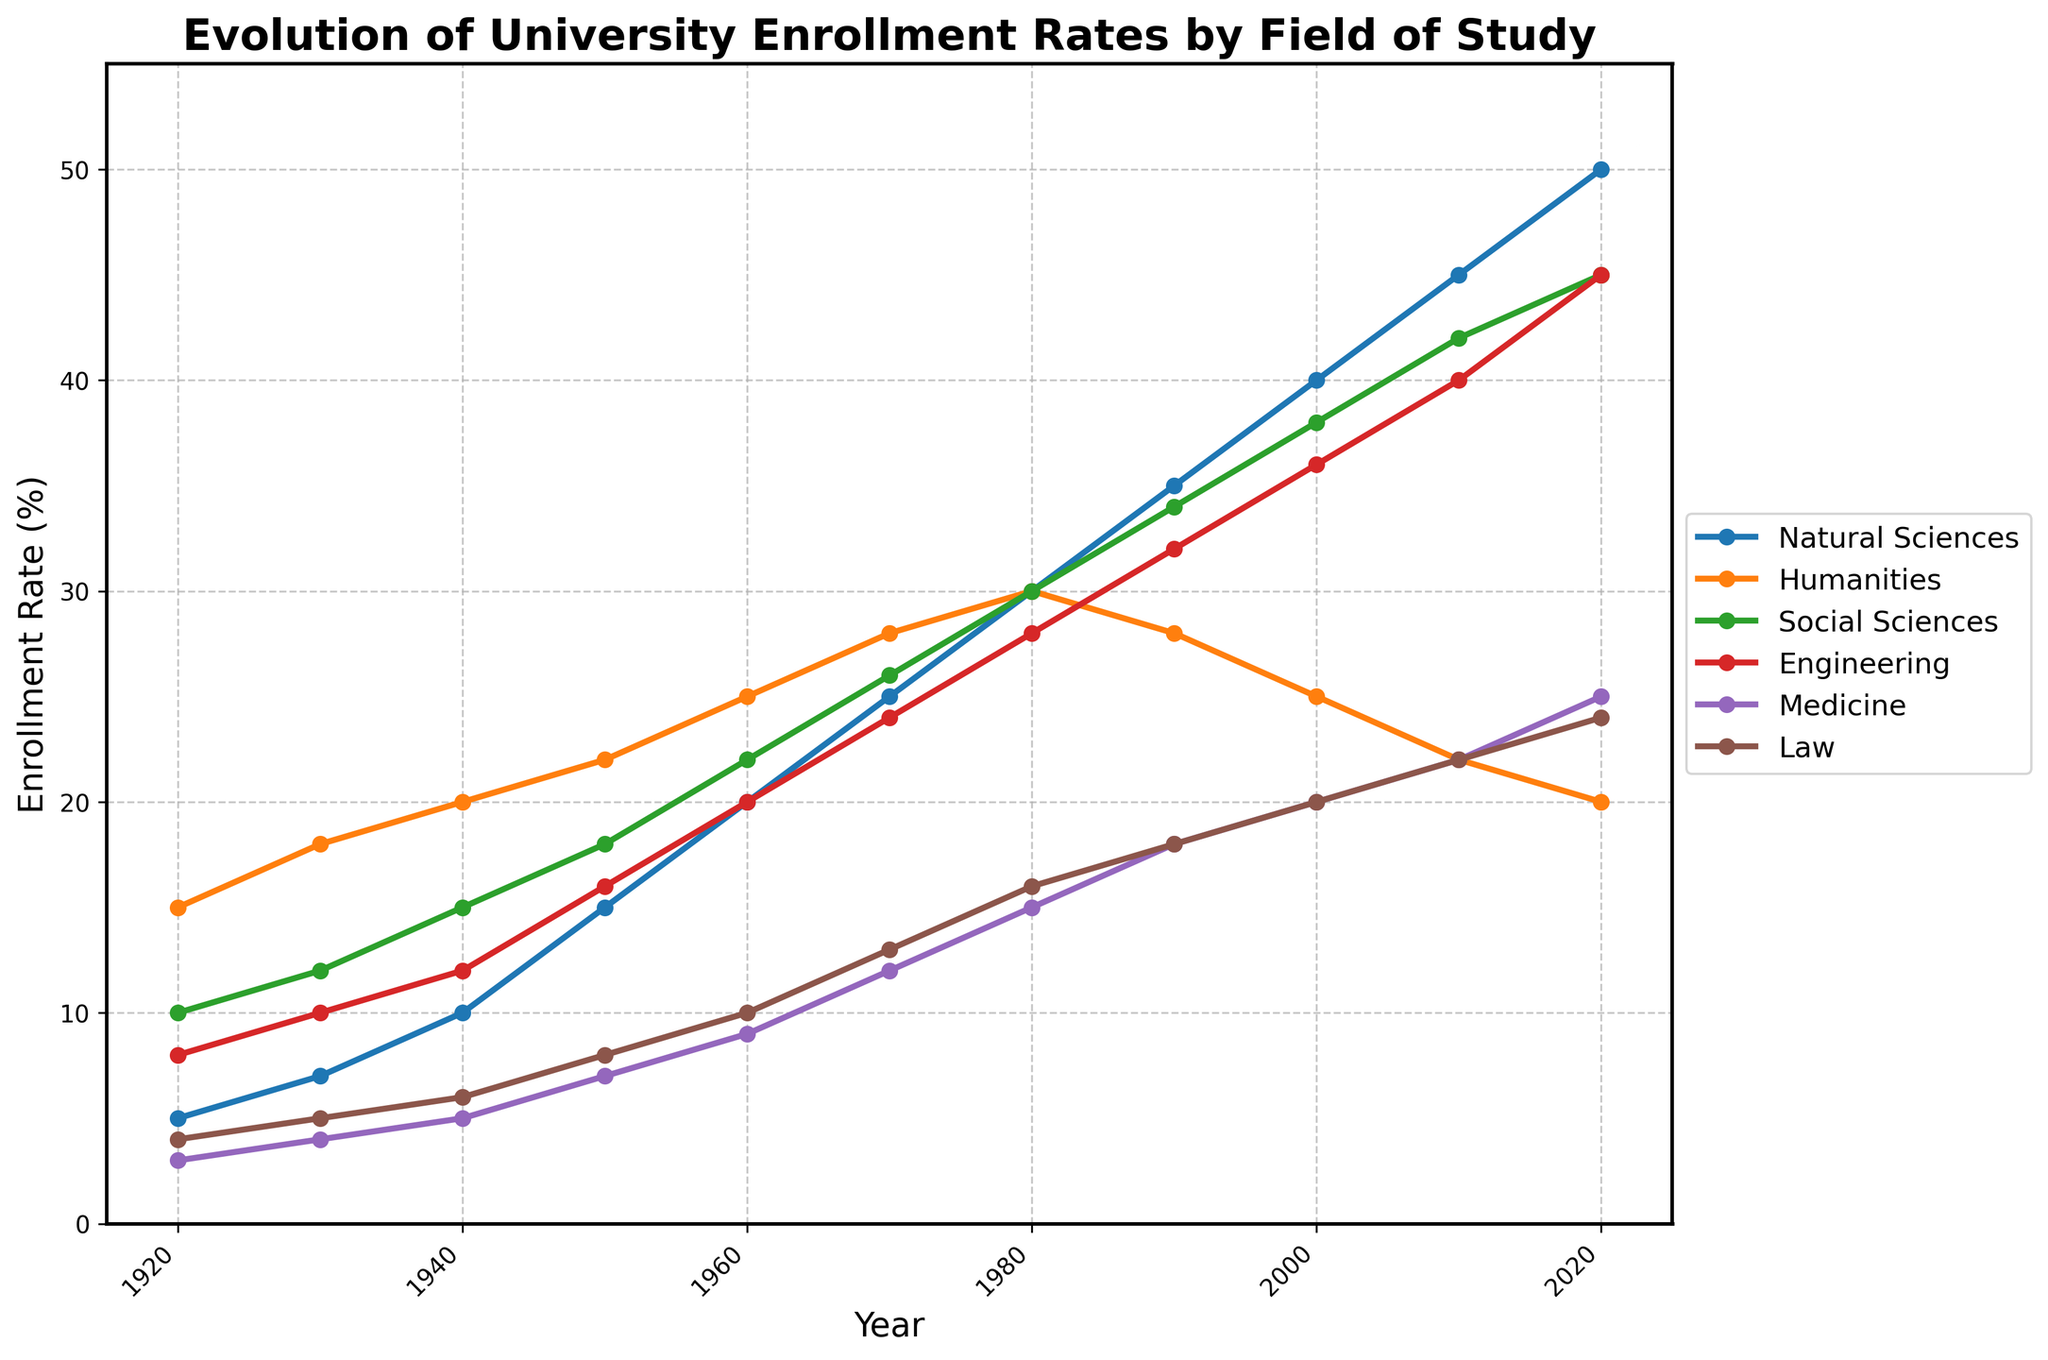What is the difference in enrollment rates between Natural Sciences and Humanities in 2020? To find the difference, look at the enrollment rates for Natural Sciences (50%) and Humanities (20%) in 2020. Subtract the Humanities rate from the Natural Sciences rate: 50% - 20% = 30%.
Answer: 30% Which field experienced the highest increase in enrollment rate from 1920 to 2020? Compare the initial and final values for each field. Natural Sciences increased from 5% to 50%, Humanities from 15% to 20%, Social Sciences from 10% to 45%, Engineering from 8% to 45%, Medicine from 3% to 25%, and Law from 4% to 24%. Natural Sciences and Engineering both increased by 45 percentage points.
Answer: Natural Sciences and Engineering Which field had the steepest decline in enrollment rate in the past century? Compare the start and end points for each field. Humanities declined the most, from 15% in 1920 to 20% in 2020, which is a decline of 5 percentage points, while others either increased or declined less.
Answer: Humanities In which year did Engineering enrollment rates surpass those of Humanities? Track the lines representing Engineering and Humanities. Engineering enrollment rates surpassed Humanities between 1980 and 1990. Humanities were higher in 1980 (30% vs. 28%), but lower in 1990 (28% vs. 32%).
Answer: Between 1980 and 1990 Between which decades did Medicine see the most significant increase in enrollment rates? Compare the increases in enrollment rates for Medicine across each decade. from 1920 to 1930, it increases by 1 percentage point. From 1930 to 1940, by 1 point. From 1960 to 1970, by 3 points. From 1970 to 1980, by 3 points. From 1980 to 1990, by 3 points. From 1990 to 2020, Enrollment rates stayed the same.
Answer: Between 1970 and 1980 What is the average enrollment rate for Law across all the displayed years? To calculate the average, sum the Law enrollment rates for each year: 4, 5, 6, 8, 10, 13, 16, 18, 20, 22, 24. Then divide by the number of years (11). (4 + 5 + 6 + 8 + 10 + 13 + 16 + 18 + 20 + 22 + 24) / 11 = 146 / 11 ≈ 13.27.
Answer: 13.27% In what year did Social Sciences have the highest enrollment rate? Identify the peak of the Social Sciences line. The highest value is 45% in 2020.
Answer: 2020 How many fields had higher enrollment rates in 2010 compared to 1990? Compare each field's enrollment rate in 1990 to its rate in 2010. Natural Sciences increased from 35% to 45%, Humanities decreased from 28% to 22%, Social Sciences increased from 34% to 42%, Engineering increased from 32% to 40%, Medicine increased from 18% to 22%, and Law increased from 18% to 22%. Therefore, 5 fields showed an increase.
Answer: 5 fields 